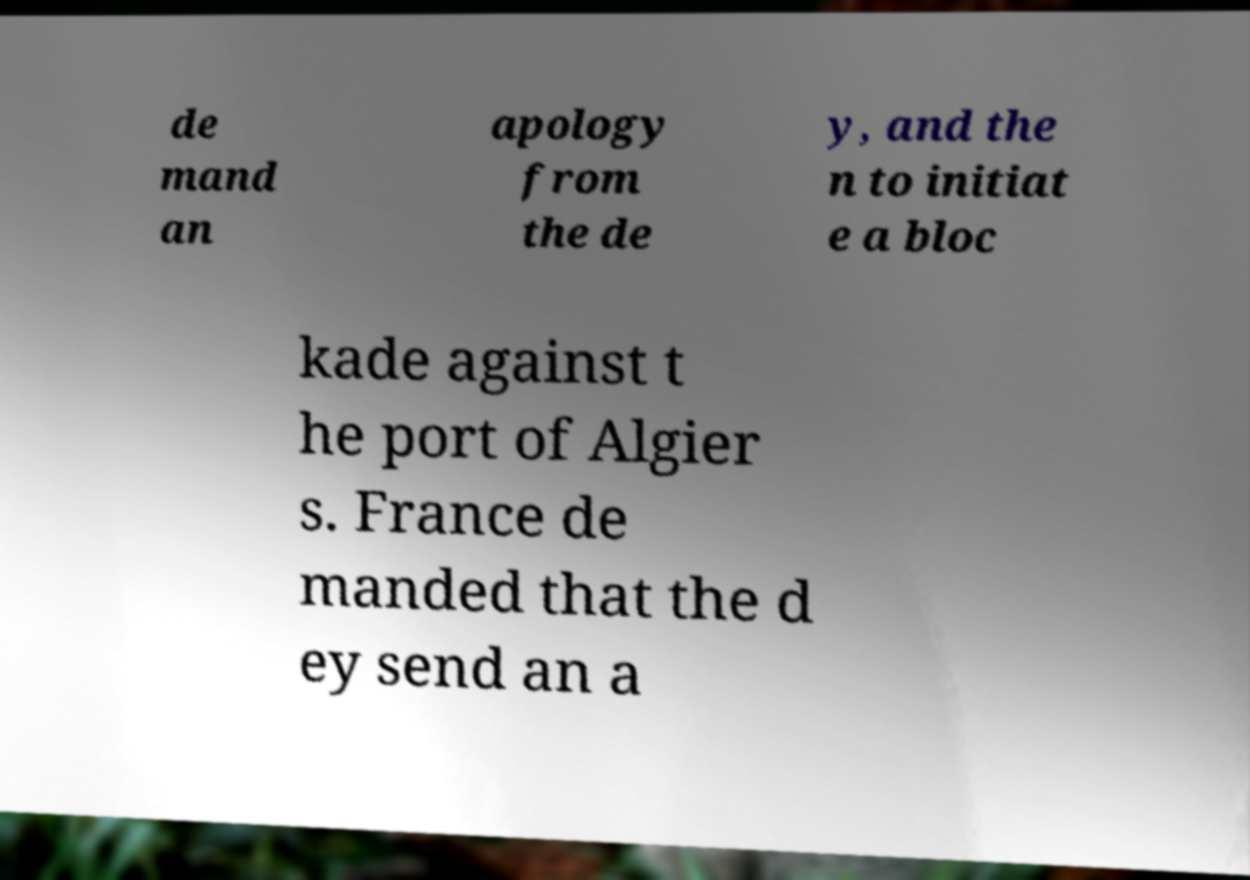There's text embedded in this image that I need extracted. Can you transcribe it verbatim? de mand an apology from the de y, and the n to initiat e a bloc kade against t he port of Algier s. France de manded that the d ey send an a 